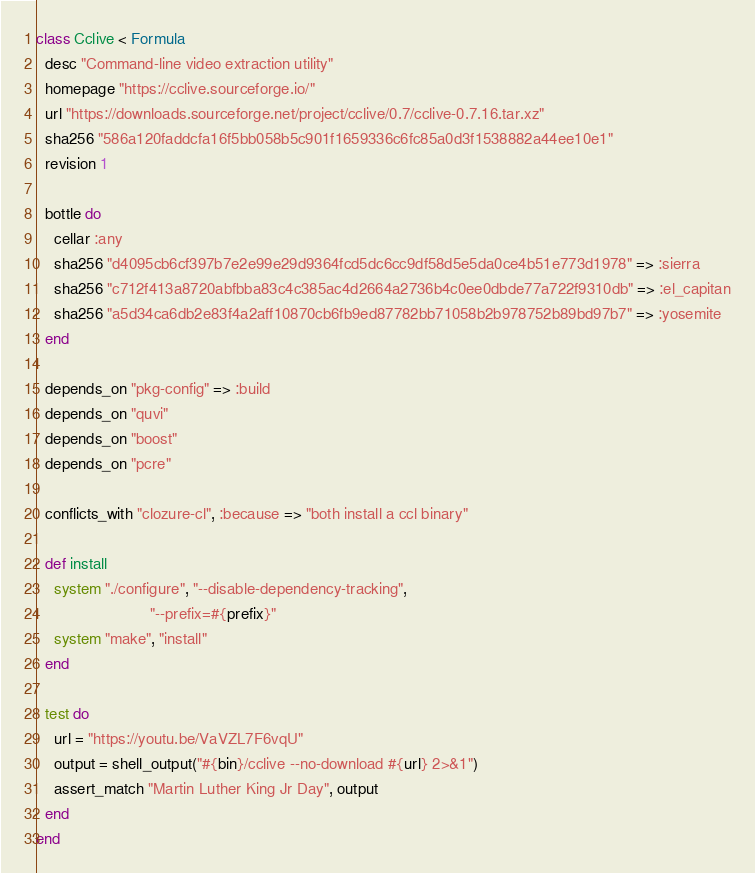Convert code to text. <code><loc_0><loc_0><loc_500><loc_500><_Ruby_>class Cclive < Formula
  desc "Command-line video extraction utility"
  homepage "https://cclive.sourceforge.io/"
  url "https://downloads.sourceforge.net/project/cclive/0.7/cclive-0.7.16.tar.xz"
  sha256 "586a120faddcfa16f5bb058b5c901f1659336c6fc85a0d3f1538882a44ee10e1"
  revision 1

  bottle do
    cellar :any
    sha256 "d4095cb6cf397b7e2e99e29d9364fcd5dc6cc9df58d5e5da0ce4b51e773d1978" => :sierra
    sha256 "c712f413a8720abfbba83c4c385ac4d2664a2736b4c0ee0dbde77a722f9310db" => :el_capitan
    sha256 "a5d34ca6db2e83f4a2aff10870cb6fb9ed87782bb71058b2b978752b89bd97b7" => :yosemite
  end

  depends_on "pkg-config" => :build
  depends_on "quvi"
  depends_on "boost"
  depends_on "pcre"

  conflicts_with "clozure-cl", :because => "both install a ccl binary"

  def install
    system "./configure", "--disable-dependency-tracking",
                          "--prefix=#{prefix}"
    system "make", "install"
  end

  test do
    url = "https://youtu.be/VaVZL7F6vqU"
    output = shell_output("#{bin}/cclive --no-download #{url} 2>&1")
    assert_match "Martin Luther King Jr Day", output
  end
end
</code> 